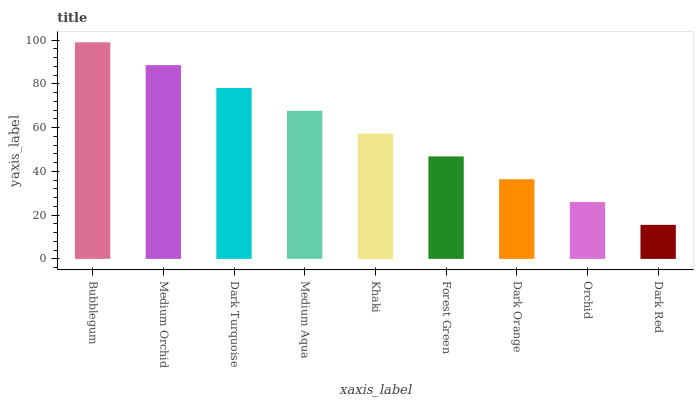Is Dark Red the minimum?
Answer yes or no. Yes. Is Bubblegum the maximum?
Answer yes or no. Yes. Is Medium Orchid the minimum?
Answer yes or no. No. Is Medium Orchid the maximum?
Answer yes or no. No. Is Bubblegum greater than Medium Orchid?
Answer yes or no. Yes. Is Medium Orchid less than Bubblegum?
Answer yes or no. Yes. Is Medium Orchid greater than Bubblegum?
Answer yes or no. No. Is Bubblegum less than Medium Orchid?
Answer yes or no. No. Is Khaki the high median?
Answer yes or no. Yes. Is Khaki the low median?
Answer yes or no. Yes. Is Medium Orchid the high median?
Answer yes or no. No. Is Dark Turquoise the low median?
Answer yes or no. No. 